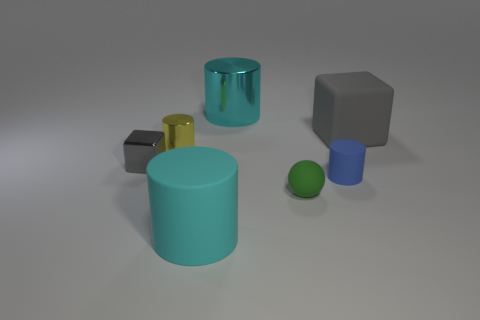There is a big cyan thing behind the big cyan matte thing that is right of the tiny metal cylinder; what is its shape?
Your answer should be compact. Cylinder. Is the small block the same color as the rubber sphere?
Your answer should be very brief. No. What number of gray objects are small shiny spheres or blocks?
Keep it short and to the point. 2. There is a blue rubber thing; are there any blue things in front of it?
Your answer should be compact. No. What size is the matte block?
Provide a succinct answer. Large. There is a blue matte object that is the same shape as the yellow object; what size is it?
Ensure brevity in your answer.  Small. How many cyan cylinders are left of the object that is behind the large gray thing?
Offer a terse response. 1. Is the block behind the tiny gray cube made of the same material as the cyan object that is in front of the rubber sphere?
Make the answer very short. Yes. How many green matte objects are the same shape as the blue thing?
Offer a terse response. 0. What number of other cylinders are the same color as the large shiny cylinder?
Your answer should be compact. 1. 